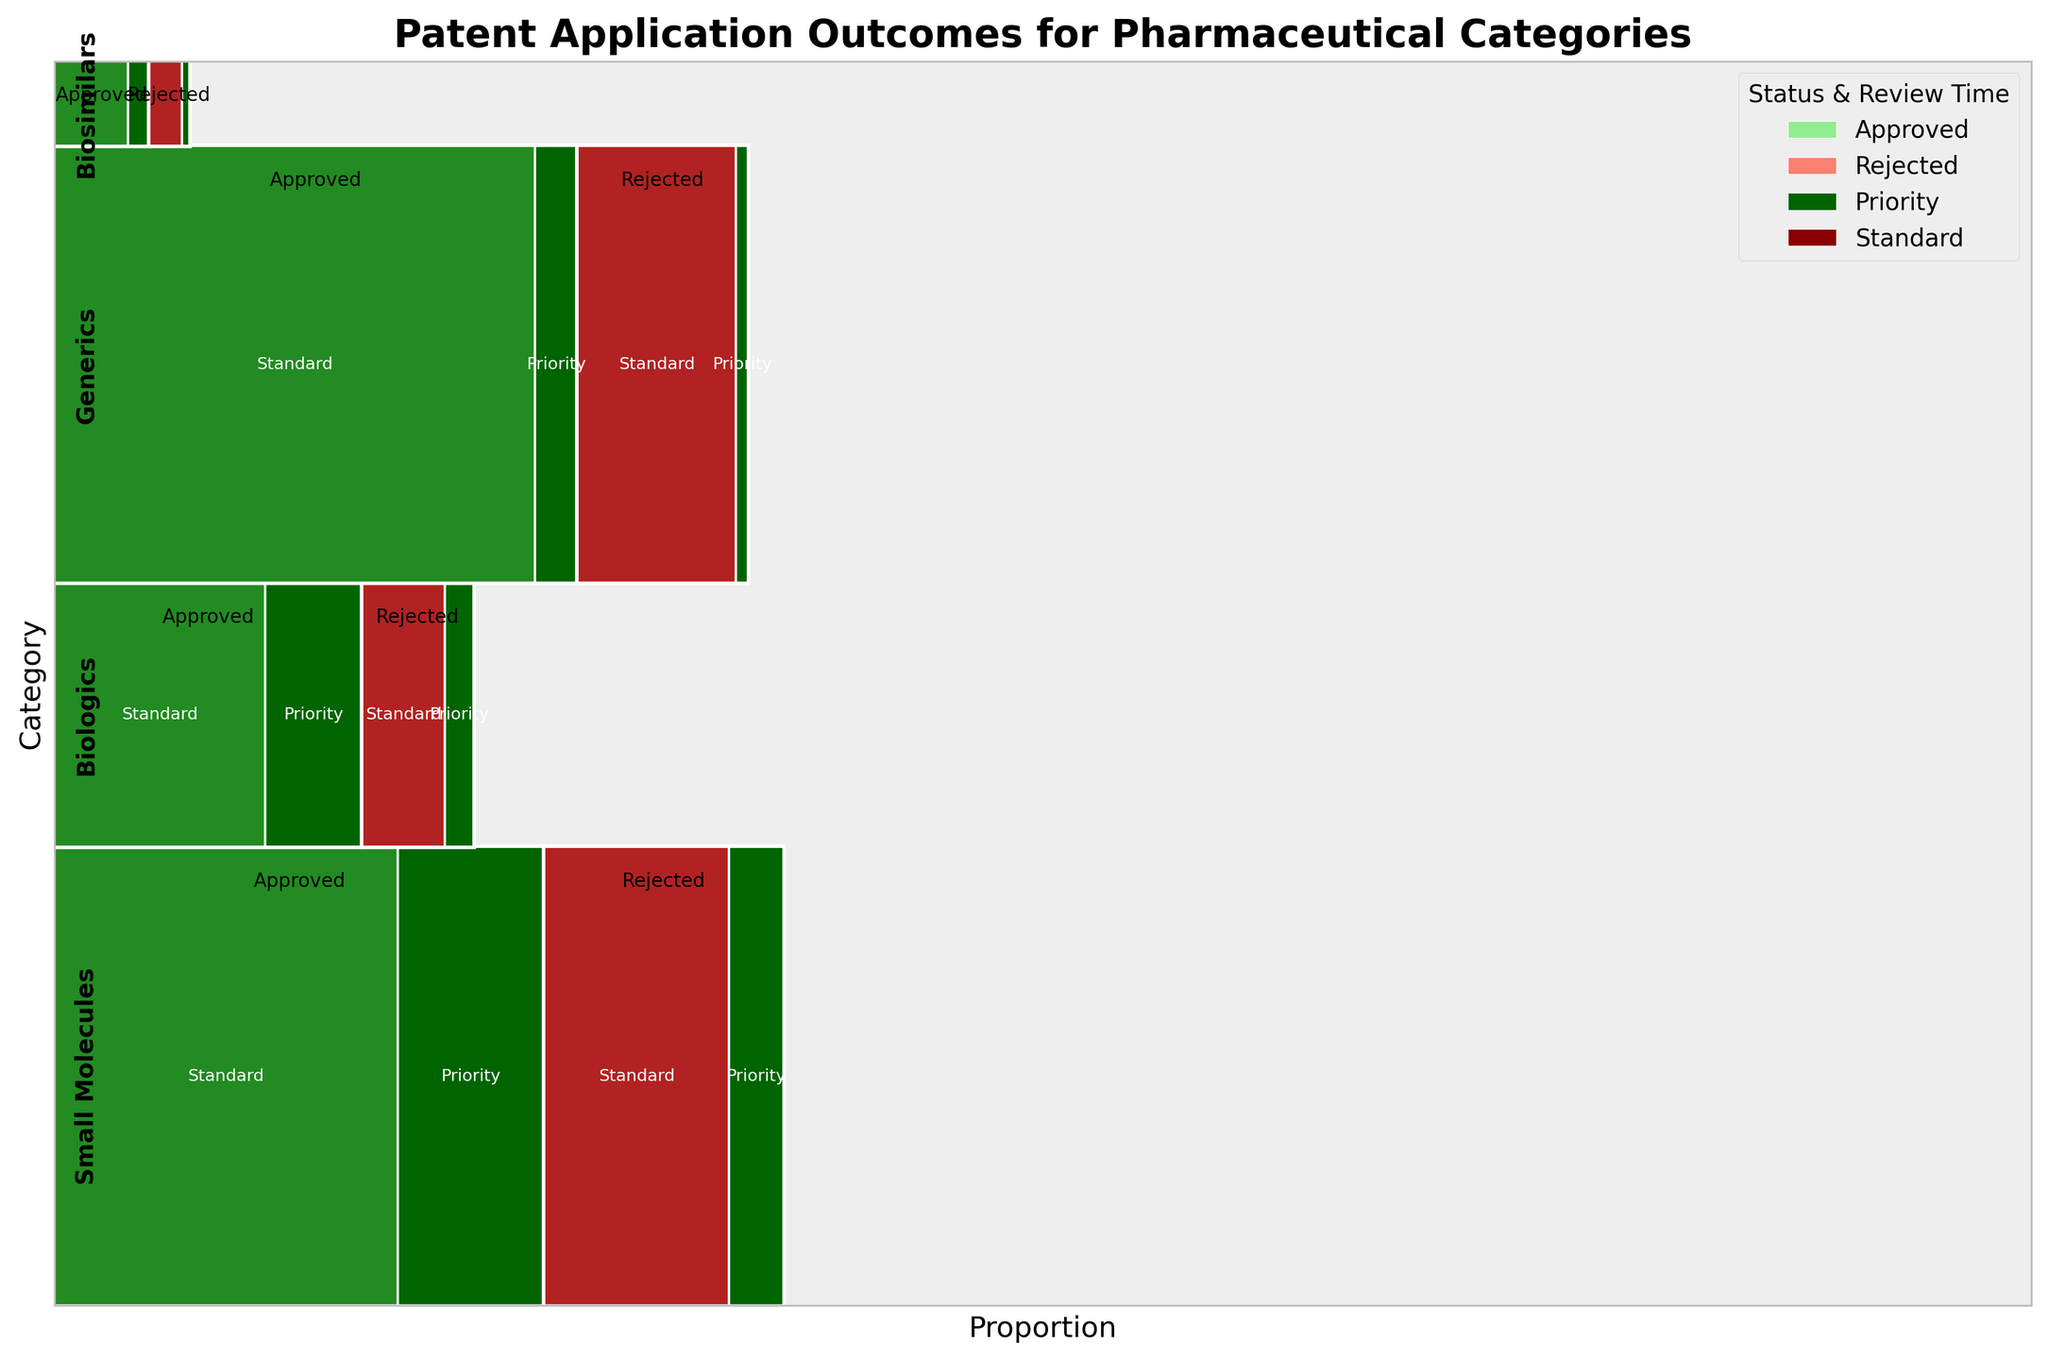What is the title of the plot? The title is placed at the top of the plot and clearly indicates the main subject.
Answer: Patent Application Outcomes for Pharmaceutical Categories Which category has the highest proportion of approved applications? Look for the largest "Approved" segment across all categories.
Answer: Generics How many review status categories are represented across the pharmaceutical categories? Note the different rectangles representing "Standard" and "Priority" within "Approved" and "Rejected" for each main category. Count the unique combinations.
Answer: Four (Approved-Standard, Approved-Priority, Rejected-Standard, Rejected-Priority) Which approval status appears to occupy more space within the 'Biologics' category, approved or rejected? Compare the height of the "Approved" and "Rejected" segments within "Biologics".
Answer: Approved Within the 'Small Molecules' category, how does the proportion of priority reviews compare between approved and rejected statuses? Compare the width of "Priority" sections within both "Approved" and "Rejected" in the "Small Molecules" category.
Answer: Higher in Approved What is the largest segment in the plot by review time and approval status across all categories? Identify the rectangle with the largest area considering combinations of review time and approval status across categories.
Answer: Generics-Approved-Standard How does the proportion of rejected applications differ between Generics and Biosimilars? Compare the size of the “Rejected” sections in the Generics and Biosimilars categories.
Answer: Generics Are there more priority or standard reviews for approved biologics? Compare the width of the "Priority" and "Standard" segments within the "Approved" status for Biologics.
Answer: Standard Which category has the lowest number of rejected priority reviews? Identify the smallest "Rejected-Priority" rectangle among all categories.
Answer: Biosimilars In which review time category do small molecules have more rejected applications? Compare the width of "Standard" and "Priority" sections within "Rejected" for Small Molecules.
Answer: Standard 